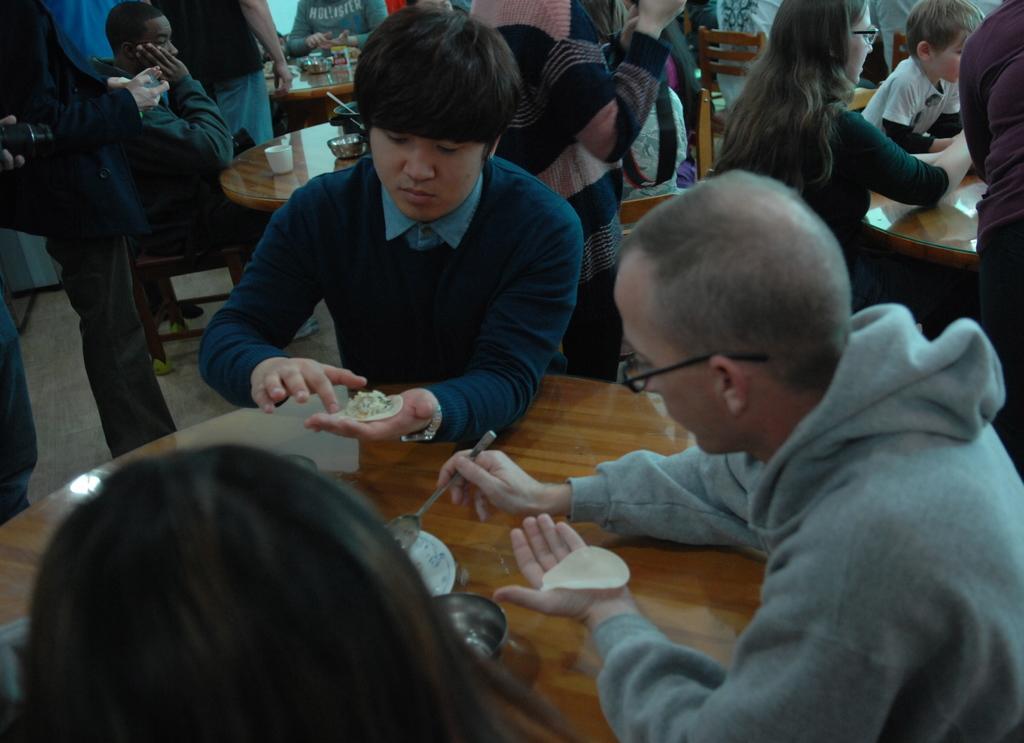Can you describe this image briefly? In this image few chairs and tables are on the floor. Few persons are sitting on the chairs. The person on the right side of the image is sitting and he is holding some food with one hand and holding a fork with the other hand. Beside him there is a person holding some food in his hand. Before him there is a table having a plate and few objects on it. Left side there is a table having a cup, bowl and few objects on it. Few persons are standing on the floor. 